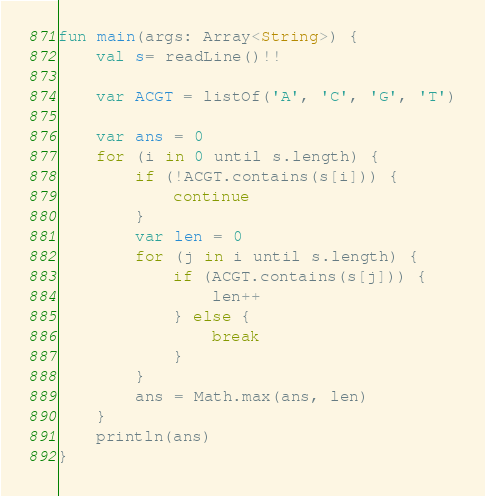<code> <loc_0><loc_0><loc_500><loc_500><_Kotlin_>fun main(args: Array<String>) {
    val s= readLine()!!

    var ACGT = listOf('A', 'C', 'G', 'T')

    var ans = 0
    for (i in 0 until s.length) {
        if (!ACGT.contains(s[i])) {
            continue
        }
        var len = 0
        for (j in i until s.length) {
            if (ACGT.contains(s[j])) {
                len++
            } else {
                break
            }
        }
        ans = Math.max(ans, len)
    }
    println(ans)
}</code> 